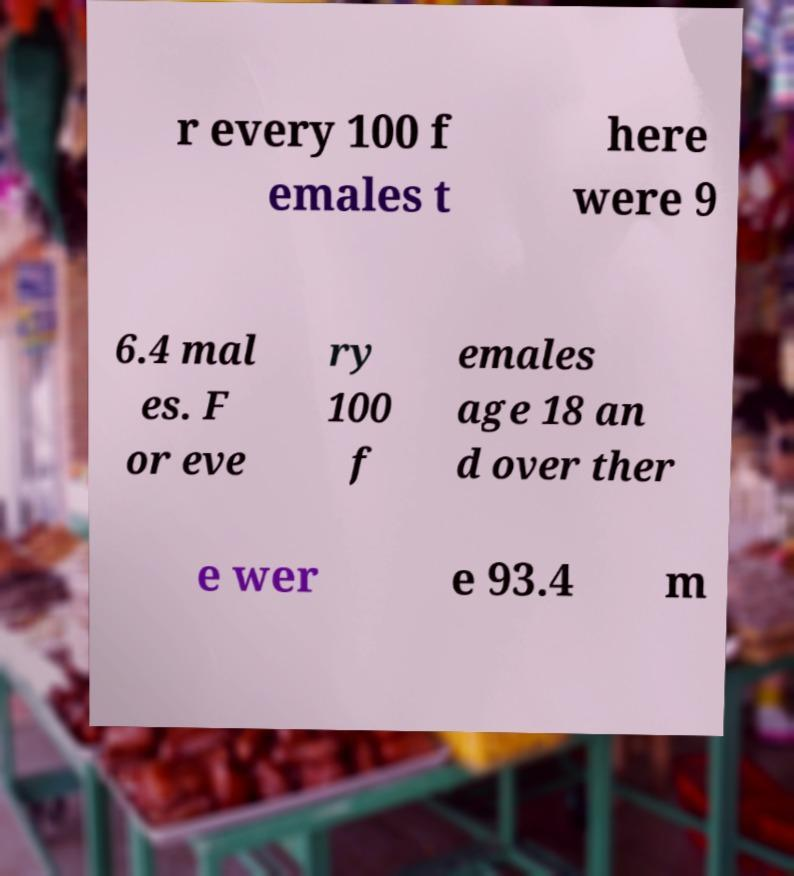Please read and relay the text visible in this image. What does it say? r every 100 f emales t here were 9 6.4 mal es. F or eve ry 100 f emales age 18 an d over ther e wer e 93.4 m 